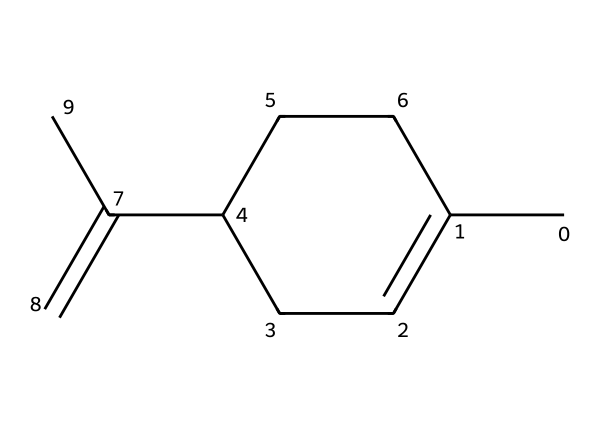What is the total number of carbon atoms in limonene? By analyzing the provided SMILES representation (CC1=CCC(CC1)C(=C)C), we can count the 'C' characters, which represent carbon atoms. In this case, there are 10 carbon atoms in total.
Answer: 10 How many double bonds are present in limonene? The SMILES structure indicates double bonds using '='. By examining the structure, we can identify that there are two double bonds present in limonene.
Answer: 2 Is limonene a cyclic compound? The presence of 'C1' and the subsequent 'CC1' in the SMILES denotes a ring structure, indicating that limonene is indeed a cyclic compound.
Answer: Yes What type of terpene is limonene? Limonene is classified as a monoterpene due to its structure, which is built from two isoprene units, resulting in a C10H16 formula.
Answer: Monoterpene What functional groups are present in limonene? Limonene does not contain any hydroxyl (–OH) or carbonyl (C=O) groups. Its structure solely consists of carbon-carbon and carbon-hydrogen bonds, indicating it is an alkene terpenoid without other functional groups.
Answer: None Which part of limonene contributes to its citrus scent? The specific arrangement of C=C double bonds and the overall hydrocarbon skeleton in its structure leads to the characteristic citrus aroma, primarily due to the presence of its unsaturated bonds.
Answer: C=C double bonds What is the saturation level of limonene? Limonene has two double bonds, indicating that it is unsaturated. The number of hydrogen atoms is lower than it would be for a fully saturated hydrocarbon with the same number of carbon atoms.
Answer: Unsaturated 